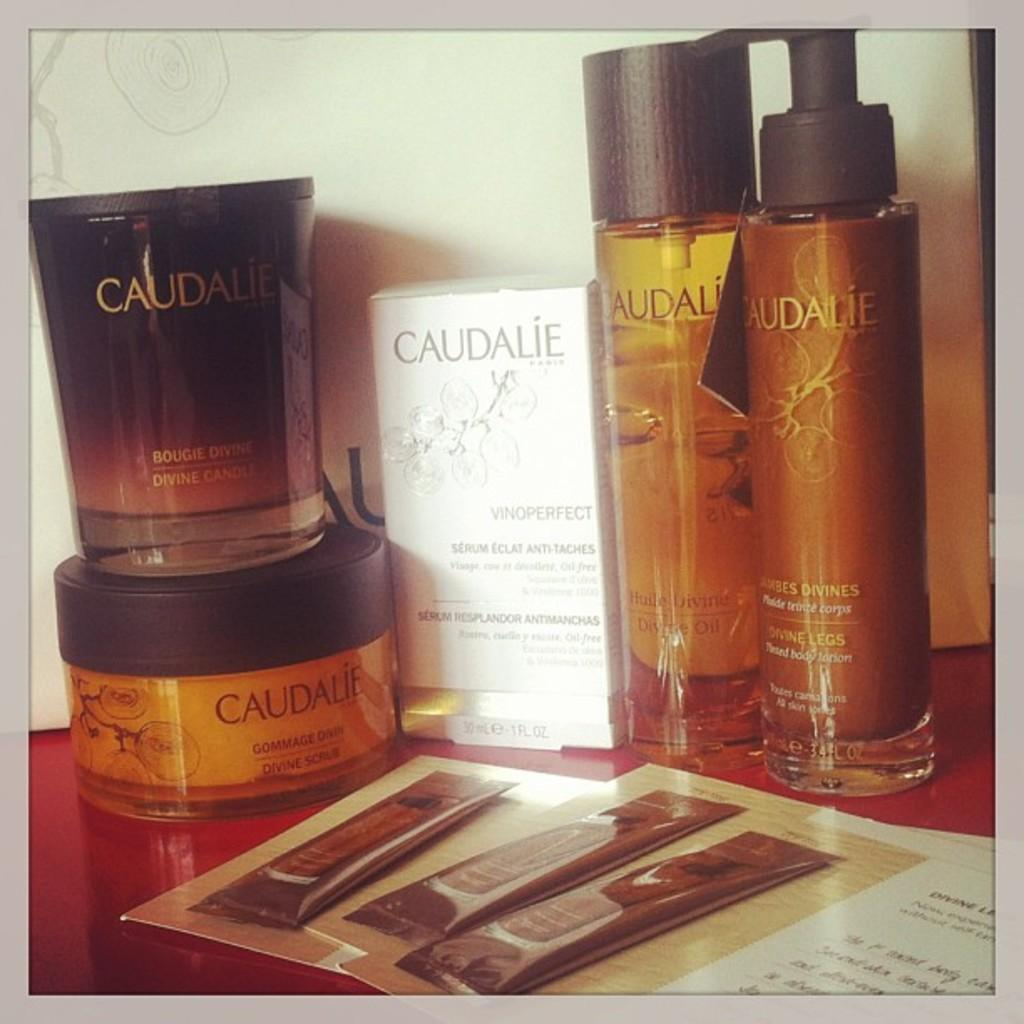<image>
Provide a brief description of the given image. Caudalie products including box and bottles on top of a table. 